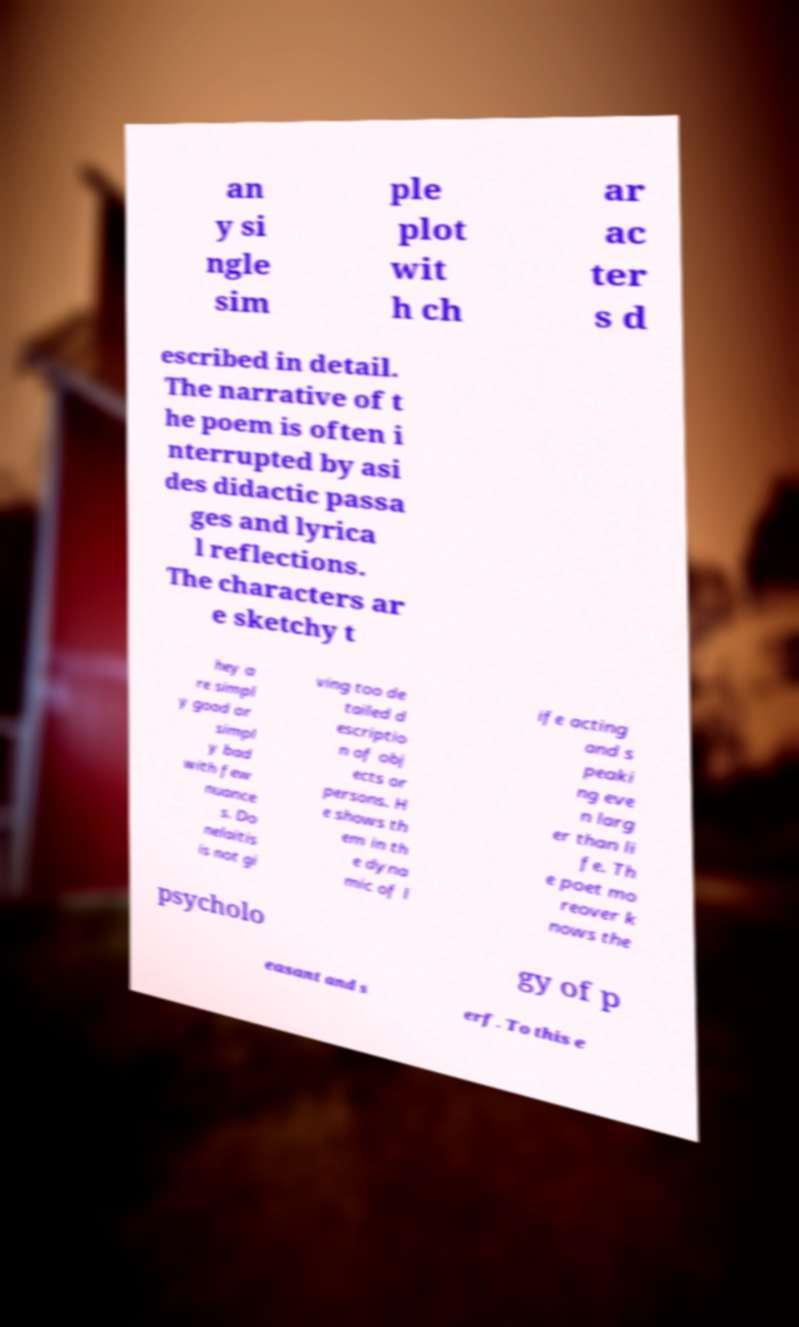I need the written content from this picture converted into text. Can you do that? an y si ngle sim ple plot wit h ch ar ac ter s d escribed in detail. The narrative of t he poem is often i nterrupted by asi des didactic passa ges and lyrica l reflections. The characters ar e sketchy t hey a re simpl y good or simpl y bad with few nuance s. Do nelaitis is not gi ving too de tailed d escriptio n of obj ects or persons. H e shows th em in th e dyna mic of l ife acting and s peaki ng eve n larg er than li fe. Th e poet mo reover k nows the psycholo gy of p easant and s erf. To this e 